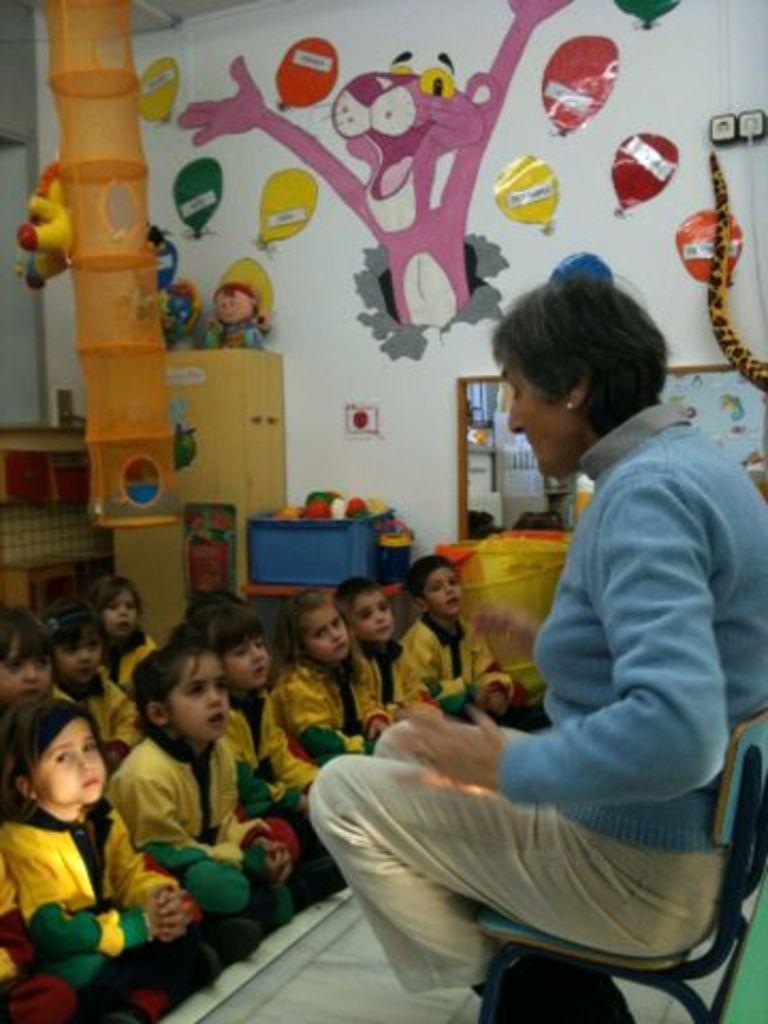In one or two sentences, can you explain what this image depicts? Here in this picture on the right side we can see an old woman sitting on the chair, which is present on the floor over there and in front of her we can see number of children sitting on the floor over there and on the walls we can see stickers present all over there and we can see toys present here and there. 